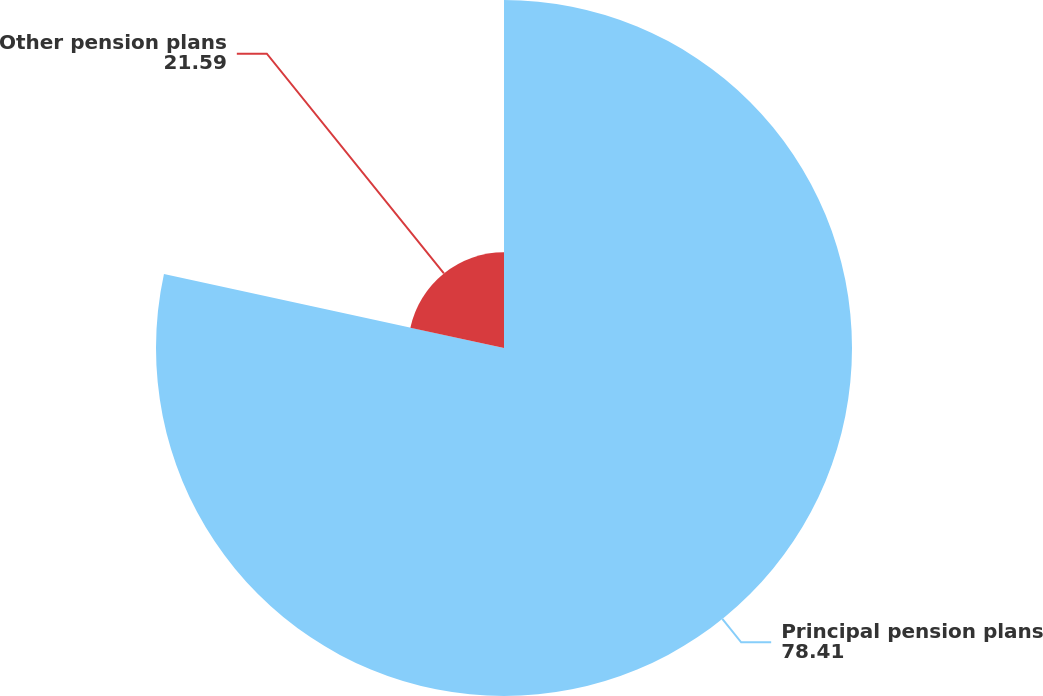Convert chart. <chart><loc_0><loc_0><loc_500><loc_500><pie_chart><fcel>Principal pension plans<fcel>Other pension plans<nl><fcel>78.41%<fcel>21.59%<nl></chart> 